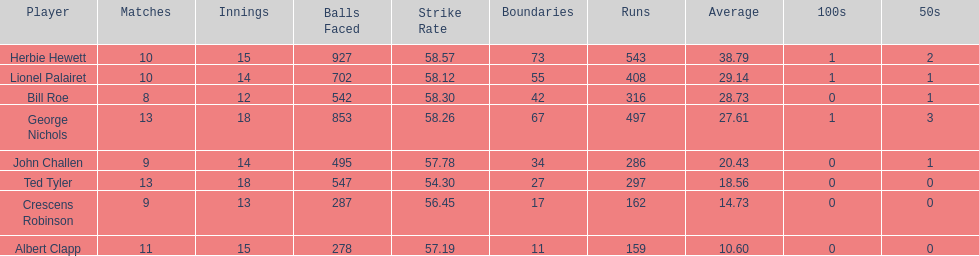How many players played more than 10 matches? 3. 